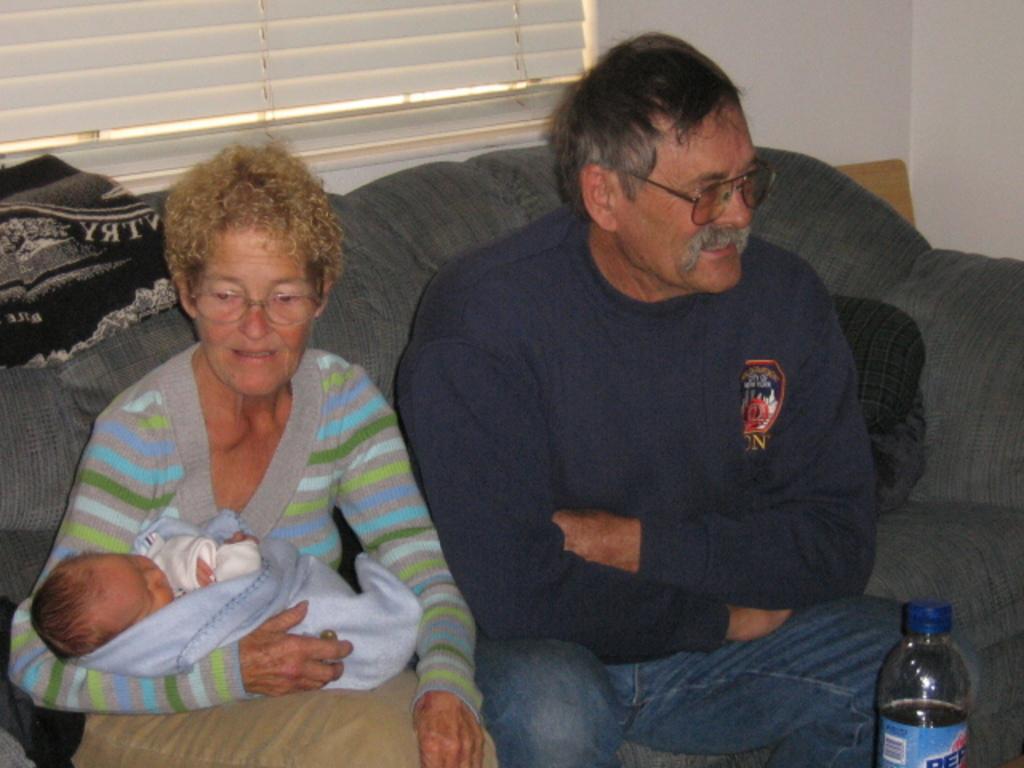Describe this image in one or two sentences. There is a room. They are sitting in a room. There is a table. There is a bottle on a table. She is holding a baby and she is wearing spectacle. 